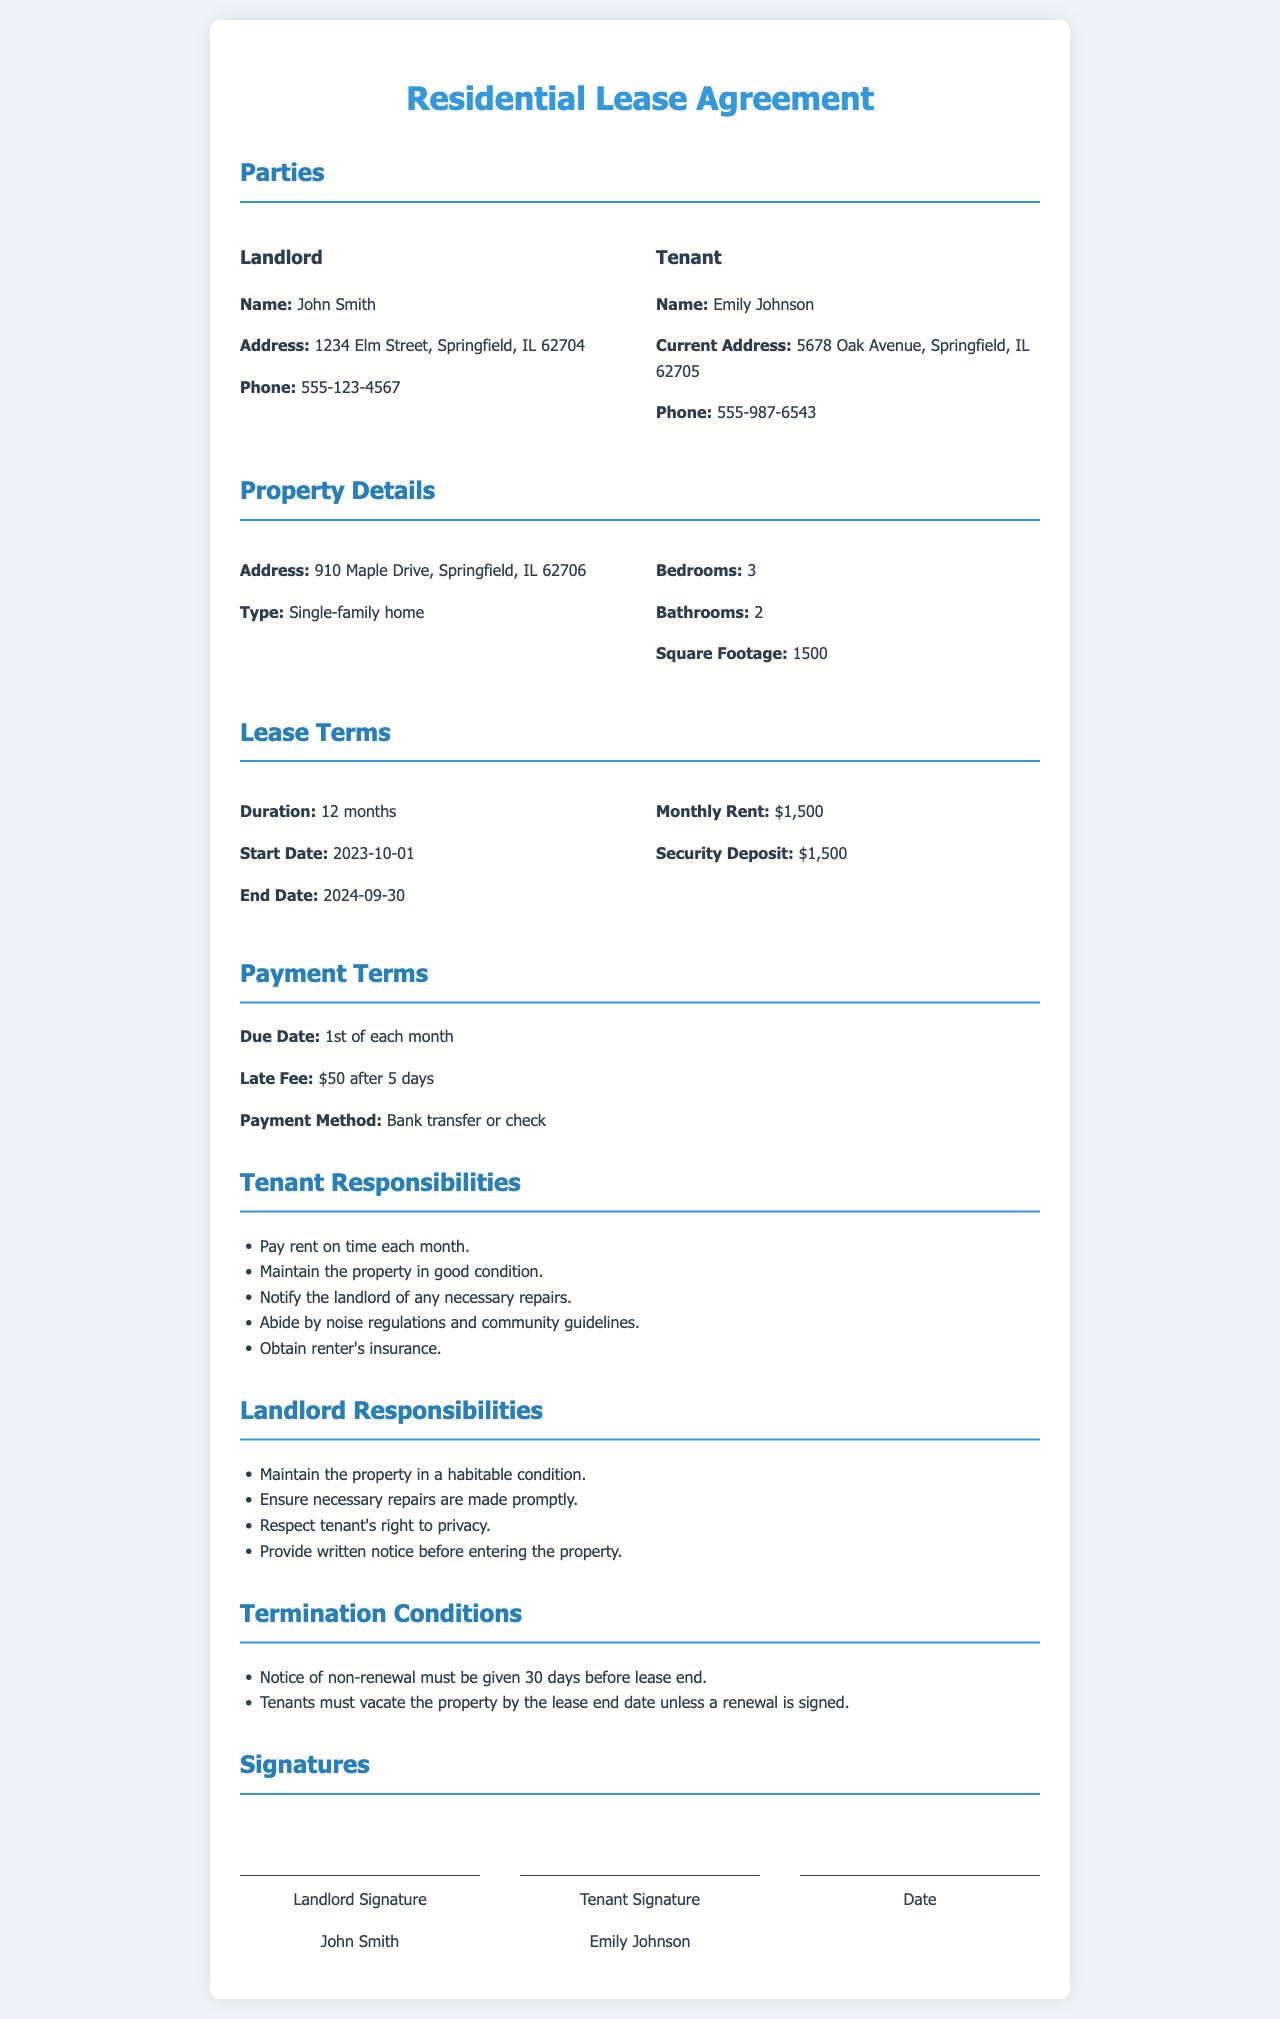What is the name of the landlord? The landlord's name is explicitly mentioned in the document as John Smith.
Answer: John Smith What is the start date of the lease? The start date of the lease is specified under the lease terms section.
Answer: 2023-10-01 What is the security deposit amount? The security deposit is listed in the lease terms section as a specific amount.
Answer: $1,500 How many bedrooms does the property have? The number of bedrooms is clearly outlined in the property details section.
Answer: 3 What is the monthly rent? The monthly rent amount is specifically provided in the lease terms section.
Answer: $1,500 What is the late fee for late payment? The late fee is detailed under the payment terms section as the consequence of late rent.
Answer: $50 What must tenants do before the lease end if they do not wish to renew? This condition is stated under the termination conditions section, specifying tenant's responsibilities.
Answer: 30 days What type of property is being leased? The type of property is mentioned in the property details section.
Answer: Single-family home What must the tenant obtain as part of their responsibilities? This responsibility is explicitly stated in the tenant responsibilities section.
Answer: Renter's insurance 